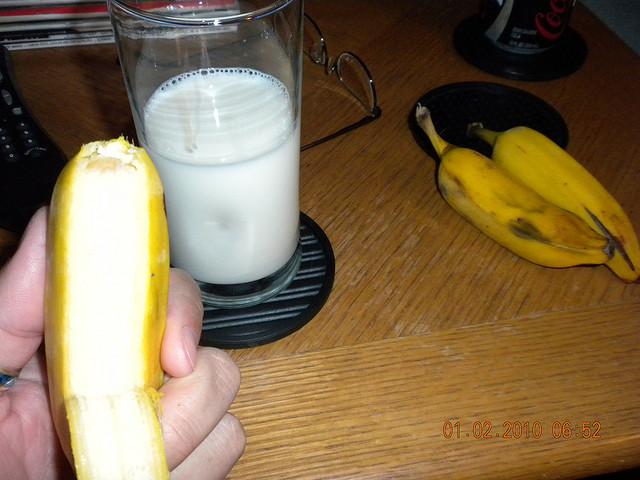What is in the glass?
Give a very brief answer. Milk. Is the banana ripe?
Keep it brief. Yes. What type of fruit is by the cup?
Keep it brief. Banana. 